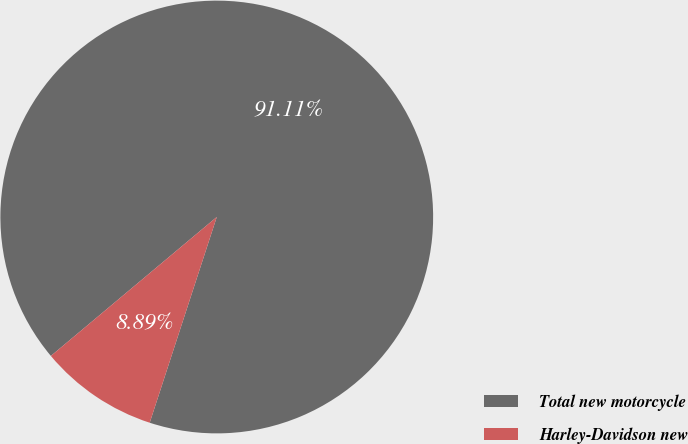<chart> <loc_0><loc_0><loc_500><loc_500><pie_chart><fcel>Total new motorcycle<fcel>Harley-Davidson new<nl><fcel>91.11%<fcel>8.89%<nl></chart> 